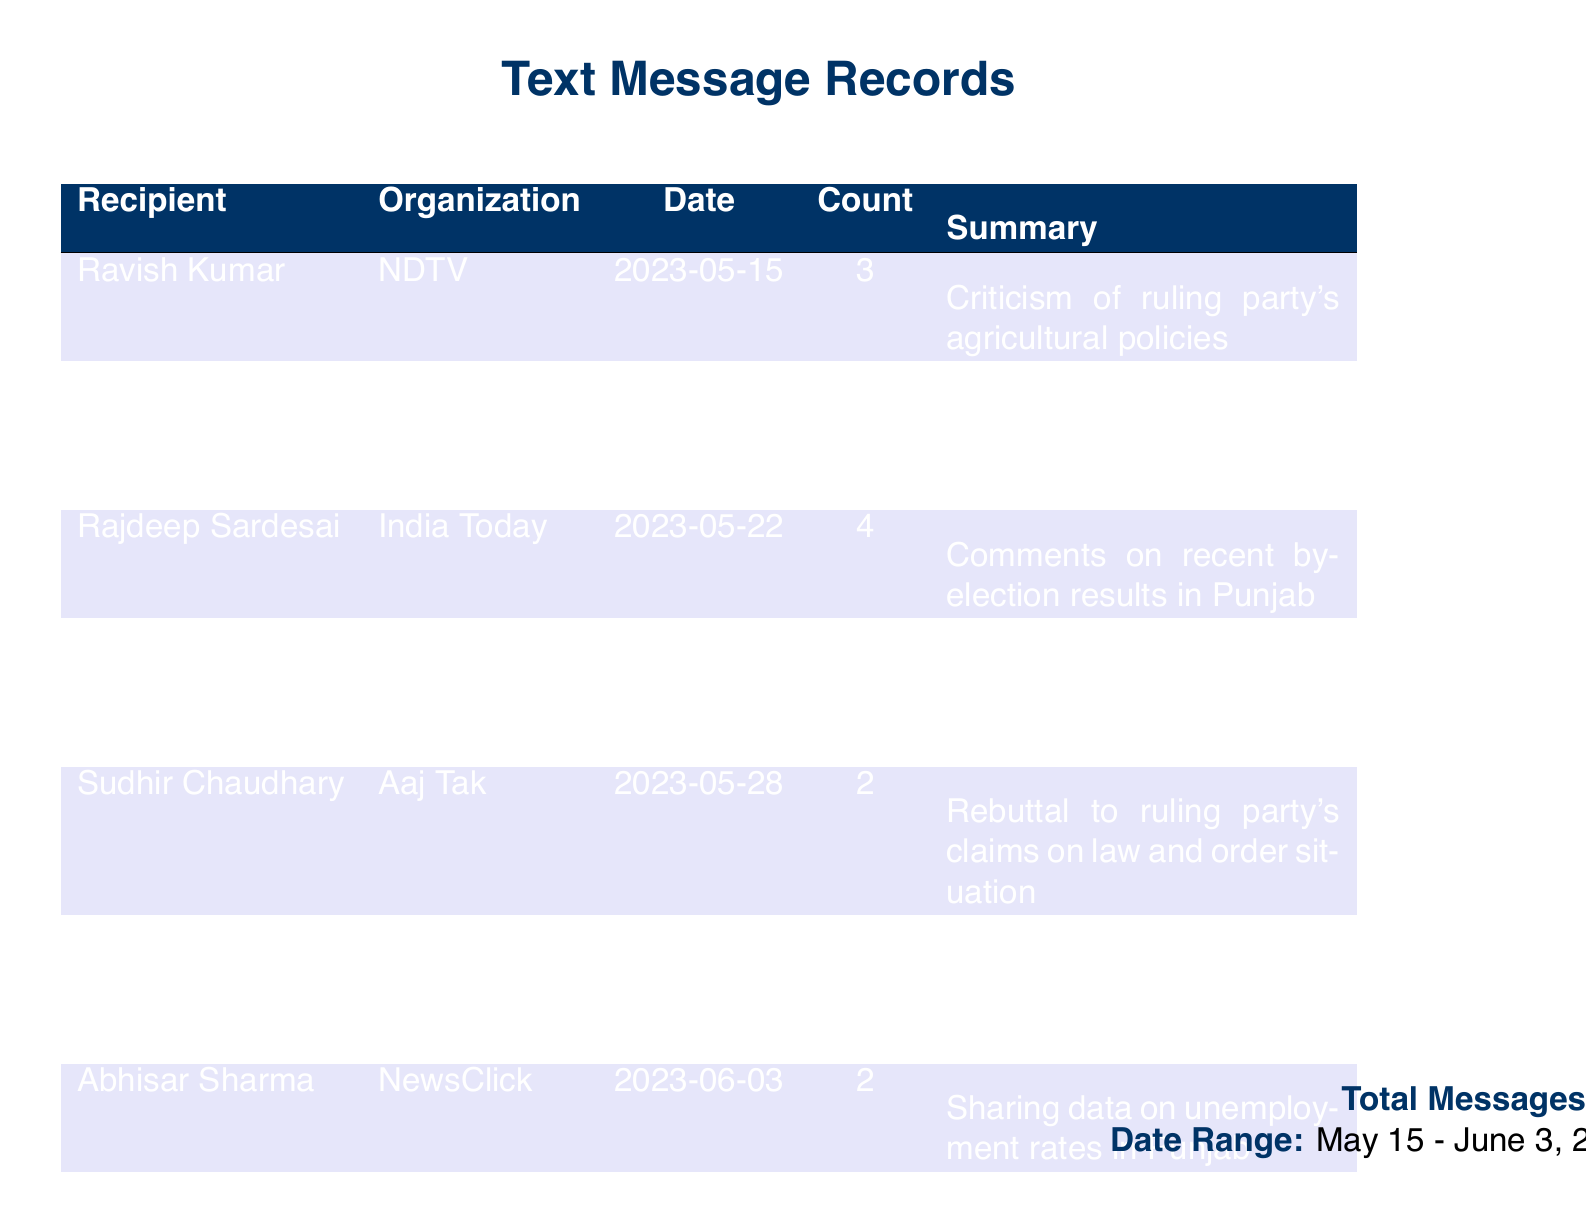What is the total count of messages? The total count of messages is noted at the bottom of the document, which is 17.
Answer: 17 Who sent messages to NDTV? The document lists Ravish Kumar and Sonia Singh as recipients who sent messages to NDTV.
Answer: Ravish Kumar, Sonia Singh What was the date of the message sent by Rajdeep Sardesai? The date associated with the message sent by Rajdeep Sardesai is mentioned in the table under the Date column, which is 2023-05-22.
Answer: 2023-05-22 How many messages were sent to Aaj Tak? The count of messages sent to Aaj Tak is found in the relevant row in the Count column, which is 2.
Answer: 2 What topic was addressed in the message to Barkha Dutt? The document summarizes the message sent to Barkha Dutt as an invitation for an exclusive interview on the party's economic vision.
Answer: Invitation for exclusive interview on party's economic vision Who was contacted regarding allegations of corruption? The document indicates that Shekhar Gupta was contacted regarding allegations of corruption in state infrastructure projects.
Answer: Shekhar Gupta What organization is associated with the total messages recorded? The total messages are connected with various organizations mentioned in the table, specifically identified by the Organizations column.
Answer: Multiple organizations Which recipient received the most messages? The recipient with the highest count of messages is Rajdeep Sardesai, as indicated by the Count column, which shows 4 messages.
Answer: Rajdeep Sardesai 